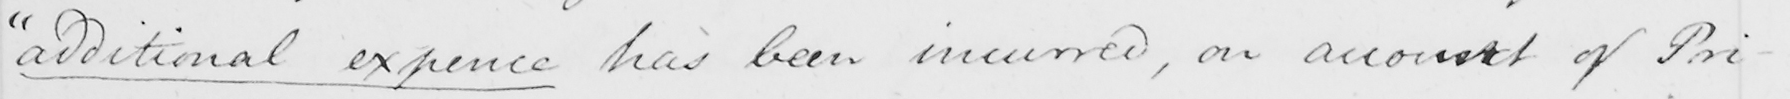What text is written in this handwritten line? " additional expence has been incurred , on account of Pri- 